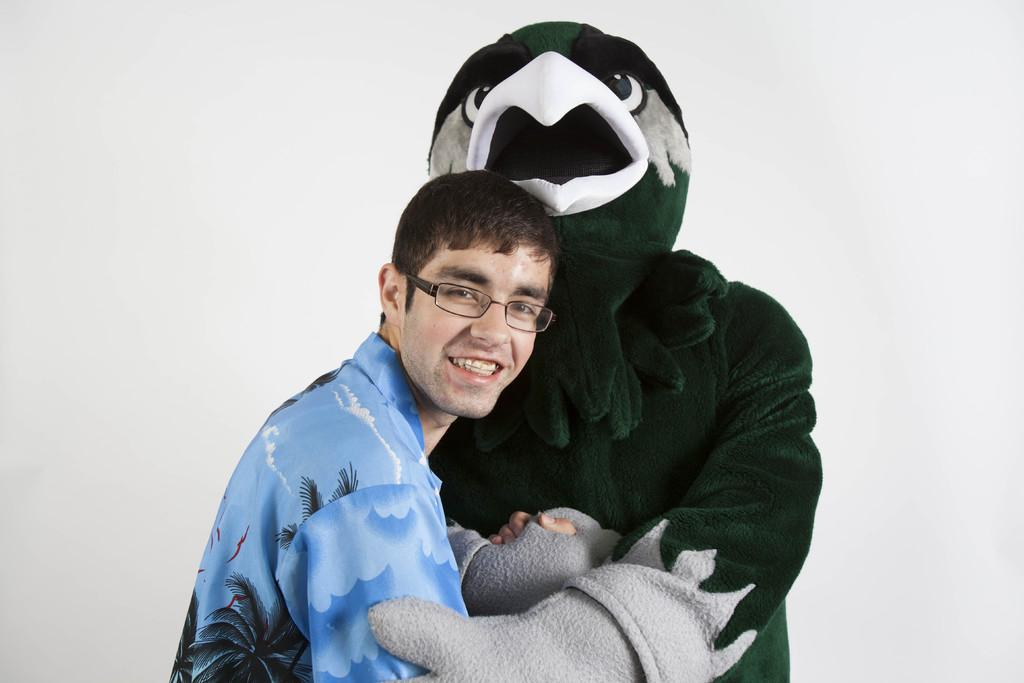Who is present in the image? There is a man in the image. What is the man wearing? The man is wearing a blue shirt. What is the man's facial expression? The man is smiling. What is the man holding in the image? The man is holding a person in a costume. What can be seen in the background of the image? There is a white surface in the background of the image. How many girls are playing with the art supplies in the image? There are no girls or art supplies present in the image. 